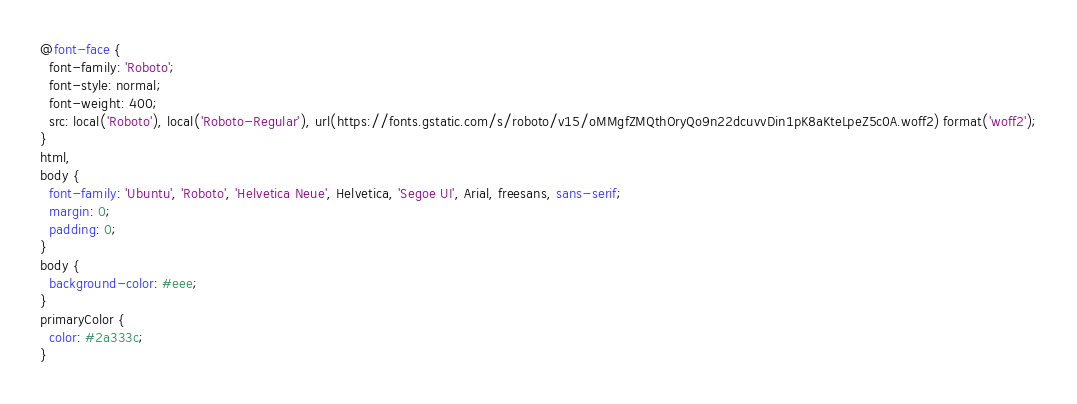<code> <loc_0><loc_0><loc_500><loc_500><_CSS_>@font-face {
  font-family: 'Roboto';
  font-style: normal;
  font-weight: 400;
  src: local('Roboto'), local('Roboto-Regular'), url(https://fonts.gstatic.com/s/roboto/v15/oMMgfZMQthOryQo9n22dcuvvDin1pK8aKteLpeZ5c0A.woff2) format('woff2');
}
html,
body {
  font-family: 'Ubuntu', 'Roboto', 'Helvetica Neue', Helvetica, 'Segoe UI', Arial, freesans, sans-serif;
  margin: 0;
  padding: 0;
}
body {
  background-color: #eee;
}
primaryColor {
  color: #2a333c;
}
</code> 